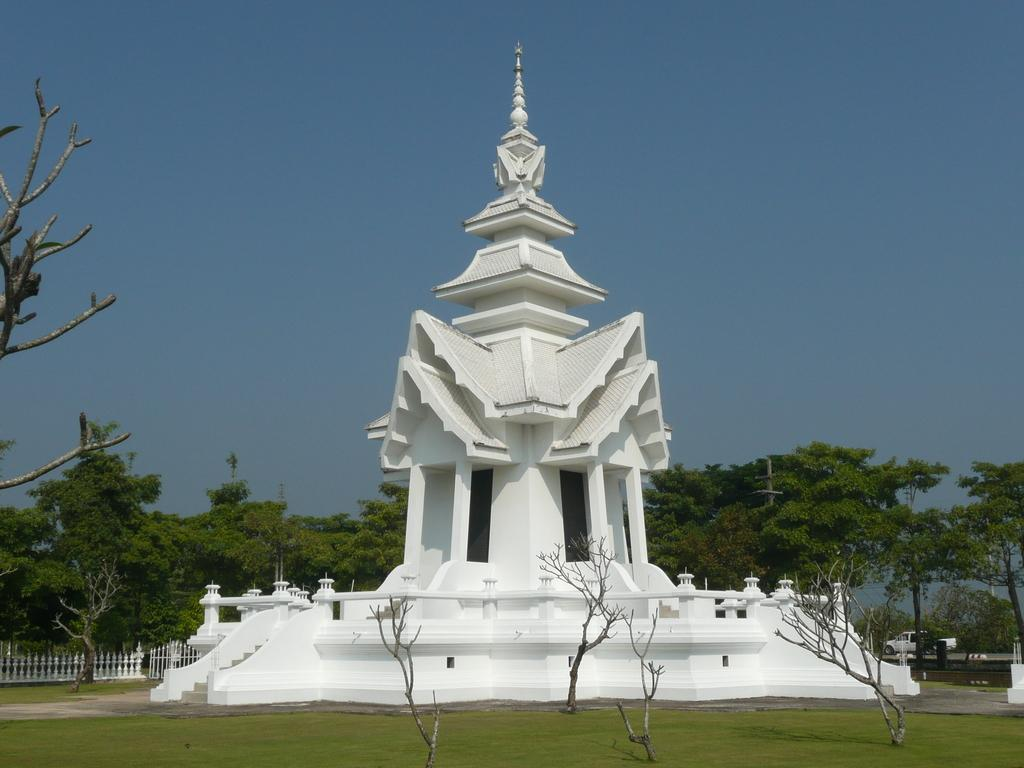What structure is the main focus of the image? There is a steeple in the image. What can be seen behind the steeple? There are trees behind the steeple. What type of barrier is visible in the image? There is a fence visible in the image. What object is present in the image that might be used for displaying signs or holding up wires? A pole is present in the image. What type of transportation can be seen in the image? There is a vehicle on a path in the image. What part of the natural environment is visible in the image? The sky is visible behind the trees. What type of zephyr can be seen blowing through the trees in the image? There is no zephyr present in the image; it is a still image with no movement or wind visible. 